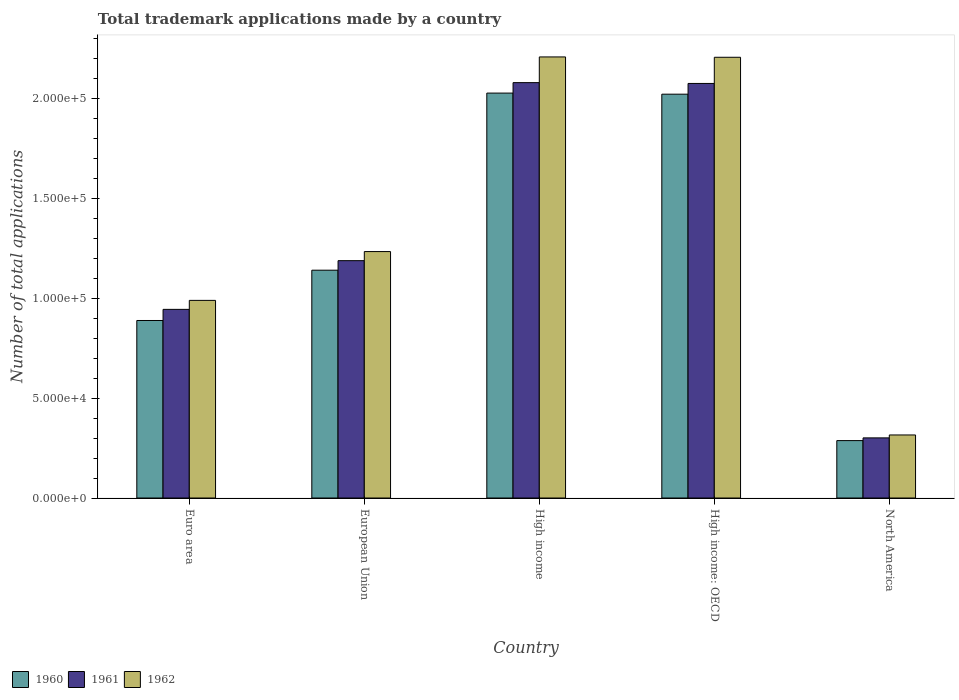Are the number of bars per tick equal to the number of legend labels?
Offer a very short reply. Yes. Are the number of bars on each tick of the X-axis equal?
Your response must be concise. Yes. How many bars are there on the 5th tick from the left?
Make the answer very short. 3. What is the number of applications made by in 1961 in High income?
Your response must be concise. 2.08e+05. Across all countries, what is the maximum number of applications made by in 1962?
Your answer should be compact. 2.21e+05. Across all countries, what is the minimum number of applications made by in 1961?
Your answer should be very brief. 3.01e+04. In which country was the number of applications made by in 1960 maximum?
Offer a terse response. High income. What is the total number of applications made by in 1962 in the graph?
Your answer should be very brief. 6.95e+05. What is the difference between the number of applications made by in 1962 in Euro area and that in European Union?
Offer a terse response. -2.44e+04. What is the difference between the number of applications made by in 1961 in High income: OECD and the number of applications made by in 1960 in Euro area?
Provide a short and direct response. 1.19e+05. What is the average number of applications made by in 1960 per country?
Offer a terse response. 1.27e+05. What is the difference between the number of applications made by of/in 1960 and number of applications made by of/in 1961 in North America?
Your answer should be very brief. -1355. In how many countries, is the number of applications made by in 1962 greater than 60000?
Your answer should be compact. 4. What is the ratio of the number of applications made by in 1962 in European Union to that in High income: OECD?
Ensure brevity in your answer.  0.56. Is the difference between the number of applications made by in 1960 in Euro area and High income: OECD greater than the difference between the number of applications made by in 1961 in Euro area and High income: OECD?
Provide a succinct answer. No. What is the difference between the highest and the second highest number of applications made by in 1961?
Ensure brevity in your answer.  -401. What is the difference between the highest and the lowest number of applications made by in 1962?
Provide a succinct answer. 1.89e+05. What does the 3rd bar from the right in European Union represents?
Give a very brief answer. 1960. Is it the case that in every country, the sum of the number of applications made by in 1961 and number of applications made by in 1960 is greater than the number of applications made by in 1962?
Give a very brief answer. Yes. How many bars are there?
Your answer should be very brief. 15. Are all the bars in the graph horizontal?
Provide a short and direct response. No. How many countries are there in the graph?
Ensure brevity in your answer.  5. What is the difference between two consecutive major ticks on the Y-axis?
Your response must be concise. 5.00e+04. Are the values on the major ticks of Y-axis written in scientific E-notation?
Offer a very short reply. Yes. Does the graph contain any zero values?
Give a very brief answer. No. Does the graph contain grids?
Provide a succinct answer. No. Where does the legend appear in the graph?
Offer a terse response. Bottom left. How are the legend labels stacked?
Make the answer very short. Horizontal. What is the title of the graph?
Your answer should be compact. Total trademark applications made by a country. Does "1983" appear as one of the legend labels in the graph?
Offer a terse response. No. What is the label or title of the Y-axis?
Give a very brief answer. Number of total applications. What is the Number of total applications in 1960 in Euro area?
Provide a succinct answer. 8.88e+04. What is the Number of total applications of 1961 in Euro area?
Make the answer very short. 9.43e+04. What is the Number of total applications in 1962 in Euro area?
Offer a very short reply. 9.88e+04. What is the Number of total applications of 1960 in European Union?
Ensure brevity in your answer.  1.14e+05. What is the Number of total applications in 1961 in European Union?
Your answer should be compact. 1.19e+05. What is the Number of total applications in 1962 in European Union?
Your answer should be compact. 1.23e+05. What is the Number of total applications of 1960 in High income?
Ensure brevity in your answer.  2.02e+05. What is the Number of total applications in 1961 in High income?
Make the answer very short. 2.08e+05. What is the Number of total applications in 1962 in High income?
Make the answer very short. 2.21e+05. What is the Number of total applications in 1960 in High income: OECD?
Give a very brief answer. 2.02e+05. What is the Number of total applications in 1961 in High income: OECD?
Give a very brief answer. 2.07e+05. What is the Number of total applications in 1962 in High income: OECD?
Make the answer very short. 2.20e+05. What is the Number of total applications of 1960 in North America?
Your answer should be compact. 2.87e+04. What is the Number of total applications in 1961 in North America?
Ensure brevity in your answer.  3.01e+04. What is the Number of total applications of 1962 in North America?
Offer a terse response. 3.15e+04. Across all countries, what is the maximum Number of total applications of 1960?
Your response must be concise. 2.02e+05. Across all countries, what is the maximum Number of total applications in 1961?
Offer a terse response. 2.08e+05. Across all countries, what is the maximum Number of total applications in 1962?
Give a very brief answer. 2.21e+05. Across all countries, what is the minimum Number of total applications in 1960?
Offer a very short reply. 2.87e+04. Across all countries, what is the minimum Number of total applications of 1961?
Offer a very short reply. 3.01e+04. Across all countries, what is the minimum Number of total applications in 1962?
Make the answer very short. 3.15e+04. What is the total Number of total applications of 1960 in the graph?
Offer a very short reply. 6.36e+05. What is the total Number of total applications in 1961 in the graph?
Offer a very short reply. 6.58e+05. What is the total Number of total applications in 1962 in the graph?
Provide a succinct answer. 6.95e+05. What is the difference between the Number of total applications in 1960 in Euro area and that in European Union?
Ensure brevity in your answer.  -2.51e+04. What is the difference between the Number of total applications in 1961 in Euro area and that in European Union?
Keep it short and to the point. -2.44e+04. What is the difference between the Number of total applications of 1962 in Euro area and that in European Union?
Offer a terse response. -2.44e+04. What is the difference between the Number of total applications in 1960 in Euro area and that in High income?
Your answer should be compact. -1.14e+05. What is the difference between the Number of total applications of 1961 in Euro area and that in High income?
Your answer should be compact. -1.13e+05. What is the difference between the Number of total applications of 1962 in Euro area and that in High income?
Your answer should be compact. -1.22e+05. What is the difference between the Number of total applications of 1960 in Euro area and that in High income: OECD?
Ensure brevity in your answer.  -1.13e+05. What is the difference between the Number of total applications of 1961 in Euro area and that in High income: OECD?
Make the answer very short. -1.13e+05. What is the difference between the Number of total applications in 1962 in Euro area and that in High income: OECD?
Make the answer very short. -1.22e+05. What is the difference between the Number of total applications of 1960 in Euro area and that in North America?
Ensure brevity in your answer.  6.01e+04. What is the difference between the Number of total applications of 1961 in Euro area and that in North America?
Give a very brief answer. 6.43e+04. What is the difference between the Number of total applications in 1962 in Euro area and that in North America?
Offer a very short reply. 6.73e+04. What is the difference between the Number of total applications of 1960 in European Union and that in High income?
Ensure brevity in your answer.  -8.86e+04. What is the difference between the Number of total applications of 1961 in European Union and that in High income?
Make the answer very short. -8.90e+04. What is the difference between the Number of total applications of 1962 in European Union and that in High income?
Give a very brief answer. -9.73e+04. What is the difference between the Number of total applications of 1960 in European Union and that in High income: OECD?
Keep it short and to the point. -8.80e+04. What is the difference between the Number of total applications of 1961 in European Union and that in High income: OECD?
Provide a short and direct response. -8.86e+04. What is the difference between the Number of total applications of 1962 in European Union and that in High income: OECD?
Ensure brevity in your answer.  -9.72e+04. What is the difference between the Number of total applications in 1960 in European Union and that in North America?
Provide a succinct answer. 8.52e+04. What is the difference between the Number of total applications of 1961 in European Union and that in North America?
Offer a terse response. 8.86e+04. What is the difference between the Number of total applications of 1962 in European Union and that in North America?
Ensure brevity in your answer.  9.17e+04. What is the difference between the Number of total applications of 1960 in High income and that in High income: OECD?
Provide a short and direct response. 540. What is the difference between the Number of total applications in 1961 in High income and that in High income: OECD?
Provide a short and direct response. 401. What is the difference between the Number of total applications in 1962 in High income and that in High income: OECD?
Offer a terse response. 170. What is the difference between the Number of total applications of 1960 in High income and that in North America?
Your answer should be compact. 1.74e+05. What is the difference between the Number of total applications of 1961 in High income and that in North America?
Offer a very short reply. 1.78e+05. What is the difference between the Number of total applications in 1962 in High income and that in North America?
Your answer should be compact. 1.89e+05. What is the difference between the Number of total applications in 1960 in High income: OECD and that in North America?
Ensure brevity in your answer.  1.73e+05. What is the difference between the Number of total applications in 1961 in High income: OECD and that in North America?
Your answer should be compact. 1.77e+05. What is the difference between the Number of total applications in 1962 in High income: OECD and that in North America?
Offer a very short reply. 1.89e+05. What is the difference between the Number of total applications of 1960 in Euro area and the Number of total applications of 1961 in European Union?
Your response must be concise. -2.99e+04. What is the difference between the Number of total applications of 1960 in Euro area and the Number of total applications of 1962 in European Union?
Your answer should be compact. -3.45e+04. What is the difference between the Number of total applications in 1961 in Euro area and the Number of total applications in 1962 in European Union?
Your answer should be very brief. -2.89e+04. What is the difference between the Number of total applications of 1960 in Euro area and the Number of total applications of 1961 in High income?
Keep it short and to the point. -1.19e+05. What is the difference between the Number of total applications in 1960 in Euro area and the Number of total applications in 1962 in High income?
Give a very brief answer. -1.32e+05. What is the difference between the Number of total applications of 1961 in Euro area and the Number of total applications of 1962 in High income?
Make the answer very short. -1.26e+05. What is the difference between the Number of total applications of 1960 in Euro area and the Number of total applications of 1961 in High income: OECD?
Your answer should be compact. -1.19e+05. What is the difference between the Number of total applications of 1960 in Euro area and the Number of total applications of 1962 in High income: OECD?
Provide a succinct answer. -1.32e+05. What is the difference between the Number of total applications in 1961 in Euro area and the Number of total applications in 1962 in High income: OECD?
Keep it short and to the point. -1.26e+05. What is the difference between the Number of total applications in 1960 in Euro area and the Number of total applications in 1961 in North America?
Provide a short and direct response. 5.87e+04. What is the difference between the Number of total applications of 1960 in Euro area and the Number of total applications of 1962 in North America?
Give a very brief answer. 5.72e+04. What is the difference between the Number of total applications in 1961 in Euro area and the Number of total applications in 1962 in North America?
Provide a succinct answer. 6.28e+04. What is the difference between the Number of total applications in 1960 in European Union and the Number of total applications in 1961 in High income?
Your response must be concise. -9.38e+04. What is the difference between the Number of total applications of 1960 in European Union and the Number of total applications of 1962 in High income?
Provide a succinct answer. -1.07e+05. What is the difference between the Number of total applications in 1961 in European Union and the Number of total applications in 1962 in High income?
Ensure brevity in your answer.  -1.02e+05. What is the difference between the Number of total applications of 1960 in European Union and the Number of total applications of 1961 in High income: OECD?
Make the answer very short. -9.34e+04. What is the difference between the Number of total applications in 1960 in European Union and the Number of total applications in 1962 in High income: OECD?
Your answer should be compact. -1.06e+05. What is the difference between the Number of total applications in 1961 in European Union and the Number of total applications in 1962 in High income: OECD?
Make the answer very short. -1.02e+05. What is the difference between the Number of total applications of 1960 in European Union and the Number of total applications of 1961 in North America?
Keep it short and to the point. 8.39e+04. What is the difference between the Number of total applications of 1960 in European Union and the Number of total applications of 1962 in North America?
Offer a very short reply. 8.24e+04. What is the difference between the Number of total applications of 1961 in European Union and the Number of total applications of 1962 in North America?
Make the answer very short. 8.72e+04. What is the difference between the Number of total applications of 1960 in High income and the Number of total applications of 1961 in High income: OECD?
Your answer should be very brief. -4828. What is the difference between the Number of total applications of 1960 in High income and the Number of total applications of 1962 in High income: OECD?
Keep it short and to the point. -1.79e+04. What is the difference between the Number of total applications of 1961 in High income and the Number of total applications of 1962 in High income: OECD?
Your answer should be compact. -1.27e+04. What is the difference between the Number of total applications in 1960 in High income and the Number of total applications in 1961 in North America?
Make the answer very short. 1.72e+05. What is the difference between the Number of total applications of 1960 in High income and the Number of total applications of 1962 in North America?
Your answer should be compact. 1.71e+05. What is the difference between the Number of total applications in 1961 in High income and the Number of total applications in 1962 in North America?
Ensure brevity in your answer.  1.76e+05. What is the difference between the Number of total applications in 1960 in High income: OECD and the Number of total applications in 1961 in North America?
Provide a short and direct response. 1.72e+05. What is the difference between the Number of total applications of 1960 in High income: OECD and the Number of total applications of 1962 in North America?
Ensure brevity in your answer.  1.70e+05. What is the difference between the Number of total applications of 1961 in High income: OECD and the Number of total applications of 1962 in North America?
Keep it short and to the point. 1.76e+05. What is the average Number of total applications in 1960 per country?
Offer a terse response. 1.27e+05. What is the average Number of total applications in 1961 per country?
Offer a very short reply. 1.32e+05. What is the average Number of total applications in 1962 per country?
Your answer should be compact. 1.39e+05. What is the difference between the Number of total applications in 1960 and Number of total applications in 1961 in Euro area?
Keep it short and to the point. -5562. What is the difference between the Number of total applications in 1960 and Number of total applications in 1962 in Euro area?
Offer a terse response. -1.01e+04. What is the difference between the Number of total applications in 1961 and Number of total applications in 1962 in Euro area?
Your answer should be compact. -4494. What is the difference between the Number of total applications of 1960 and Number of total applications of 1961 in European Union?
Offer a very short reply. -4767. What is the difference between the Number of total applications of 1960 and Number of total applications of 1962 in European Union?
Provide a short and direct response. -9317. What is the difference between the Number of total applications of 1961 and Number of total applications of 1962 in European Union?
Your response must be concise. -4550. What is the difference between the Number of total applications in 1960 and Number of total applications in 1961 in High income?
Give a very brief answer. -5229. What is the difference between the Number of total applications of 1960 and Number of total applications of 1962 in High income?
Provide a succinct answer. -1.81e+04. What is the difference between the Number of total applications in 1961 and Number of total applications in 1962 in High income?
Provide a short and direct response. -1.29e+04. What is the difference between the Number of total applications of 1960 and Number of total applications of 1961 in High income: OECD?
Make the answer very short. -5368. What is the difference between the Number of total applications in 1960 and Number of total applications in 1962 in High income: OECD?
Offer a very short reply. -1.85e+04. What is the difference between the Number of total applications of 1961 and Number of total applications of 1962 in High income: OECD?
Offer a terse response. -1.31e+04. What is the difference between the Number of total applications of 1960 and Number of total applications of 1961 in North America?
Your answer should be very brief. -1355. What is the difference between the Number of total applications in 1960 and Number of total applications in 1962 in North America?
Provide a short and direct response. -2817. What is the difference between the Number of total applications of 1961 and Number of total applications of 1962 in North America?
Offer a terse response. -1462. What is the ratio of the Number of total applications of 1960 in Euro area to that in European Union?
Your answer should be compact. 0.78. What is the ratio of the Number of total applications in 1961 in Euro area to that in European Union?
Offer a terse response. 0.79. What is the ratio of the Number of total applications of 1962 in Euro area to that in European Union?
Give a very brief answer. 0.8. What is the ratio of the Number of total applications in 1960 in Euro area to that in High income?
Your answer should be compact. 0.44. What is the ratio of the Number of total applications in 1961 in Euro area to that in High income?
Provide a short and direct response. 0.45. What is the ratio of the Number of total applications in 1962 in Euro area to that in High income?
Your response must be concise. 0.45. What is the ratio of the Number of total applications in 1960 in Euro area to that in High income: OECD?
Make the answer very short. 0.44. What is the ratio of the Number of total applications in 1961 in Euro area to that in High income: OECD?
Offer a terse response. 0.46. What is the ratio of the Number of total applications of 1962 in Euro area to that in High income: OECD?
Offer a terse response. 0.45. What is the ratio of the Number of total applications of 1960 in Euro area to that in North America?
Give a very brief answer. 3.09. What is the ratio of the Number of total applications of 1961 in Euro area to that in North America?
Give a very brief answer. 3.14. What is the ratio of the Number of total applications of 1962 in Euro area to that in North America?
Ensure brevity in your answer.  3.13. What is the ratio of the Number of total applications in 1960 in European Union to that in High income?
Offer a very short reply. 0.56. What is the ratio of the Number of total applications in 1962 in European Union to that in High income?
Provide a succinct answer. 0.56. What is the ratio of the Number of total applications in 1960 in European Union to that in High income: OECD?
Your response must be concise. 0.56. What is the ratio of the Number of total applications in 1961 in European Union to that in High income: OECD?
Your answer should be very brief. 0.57. What is the ratio of the Number of total applications of 1962 in European Union to that in High income: OECD?
Your answer should be very brief. 0.56. What is the ratio of the Number of total applications of 1960 in European Union to that in North America?
Your answer should be very brief. 3.97. What is the ratio of the Number of total applications in 1961 in European Union to that in North America?
Offer a terse response. 3.95. What is the ratio of the Number of total applications in 1962 in European Union to that in North America?
Make the answer very short. 3.91. What is the ratio of the Number of total applications of 1961 in High income to that in High income: OECD?
Keep it short and to the point. 1. What is the ratio of the Number of total applications in 1962 in High income to that in High income: OECD?
Offer a very short reply. 1. What is the ratio of the Number of total applications in 1960 in High income to that in North America?
Provide a succinct answer. 7.05. What is the ratio of the Number of total applications of 1961 in High income to that in North America?
Make the answer very short. 6.91. What is the ratio of the Number of total applications in 1962 in High income to that in North America?
Your answer should be compact. 7. What is the ratio of the Number of total applications of 1960 in High income: OECD to that in North America?
Your response must be concise. 7.03. What is the ratio of the Number of total applications in 1961 in High income: OECD to that in North America?
Ensure brevity in your answer.  6.9. What is the ratio of the Number of total applications in 1962 in High income: OECD to that in North America?
Give a very brief answer. 6.99. What is the difference between the highest and the second highest Number of total applications of 1960?
Give a very brief answer. 540. What is the difference between the highest and the second highest Number of total applications of 1961?
Keep it short and to the point. 401. What is the difference between the highest and the second highest Number of total applications in 1962?
Offer a terse response. 170. What is the difference between the highest and the lowest Number of total applications in 1960?
Offer a very short reply. 1.74e+05. What is the difference between the highest and the lowest Number of total applications in 1961?
Provide a succinct answer. 1.78e+05. What is the difference between the highest and the lowest Number of total applications in 1962?
Offer a very short reply. 1.89e+05. 